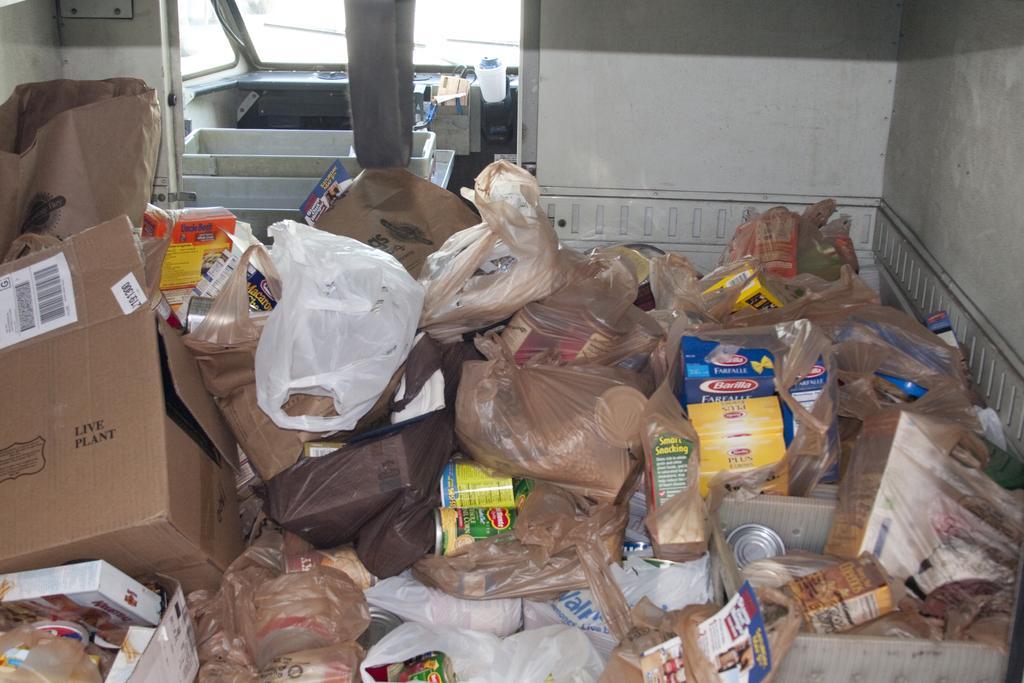In one or two sentences, can you explain what this image depicts? In this picture there are cardboard boxes and there are covers and tins. At the back it looks like a vehicle and there are objects. 